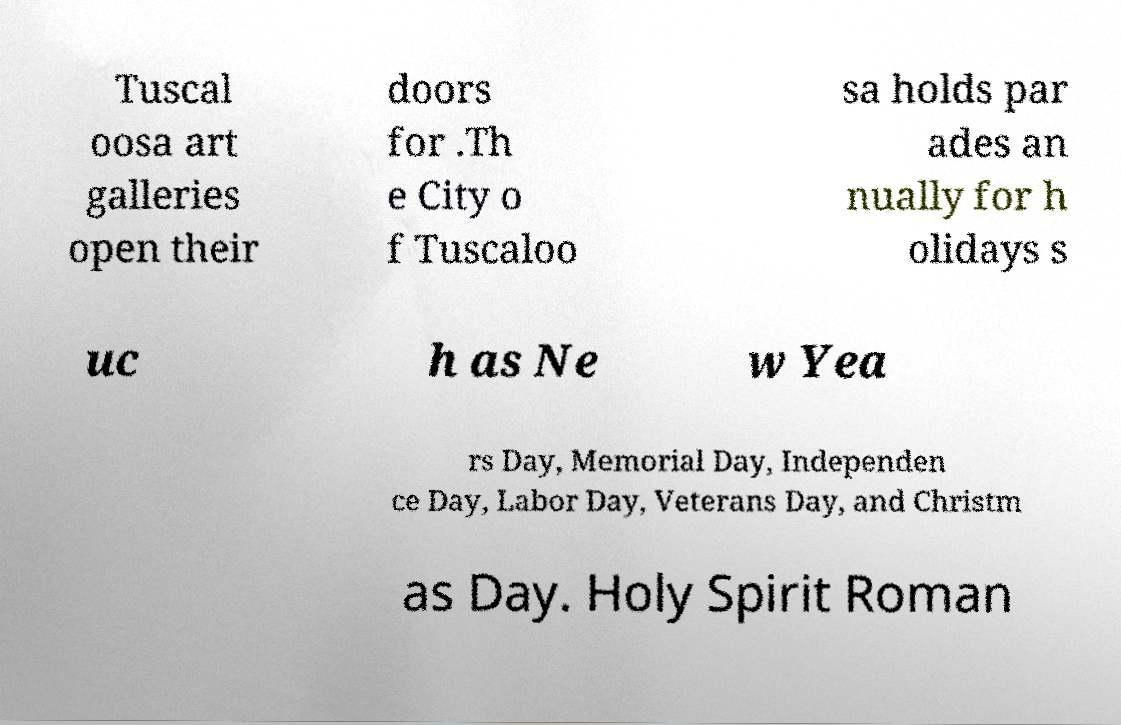Could you extract and type out the text from this image? Tuscal oosa art galleries open their doors for .Th e City o f Tuscaloo sa holds par ades an nually for h olidays s uc h as Ne w Yea rs Day, Memorial Day, Independen ce Day, Labor Day, Veterans Day, and Christm as Day. Holy Spirit Roman 